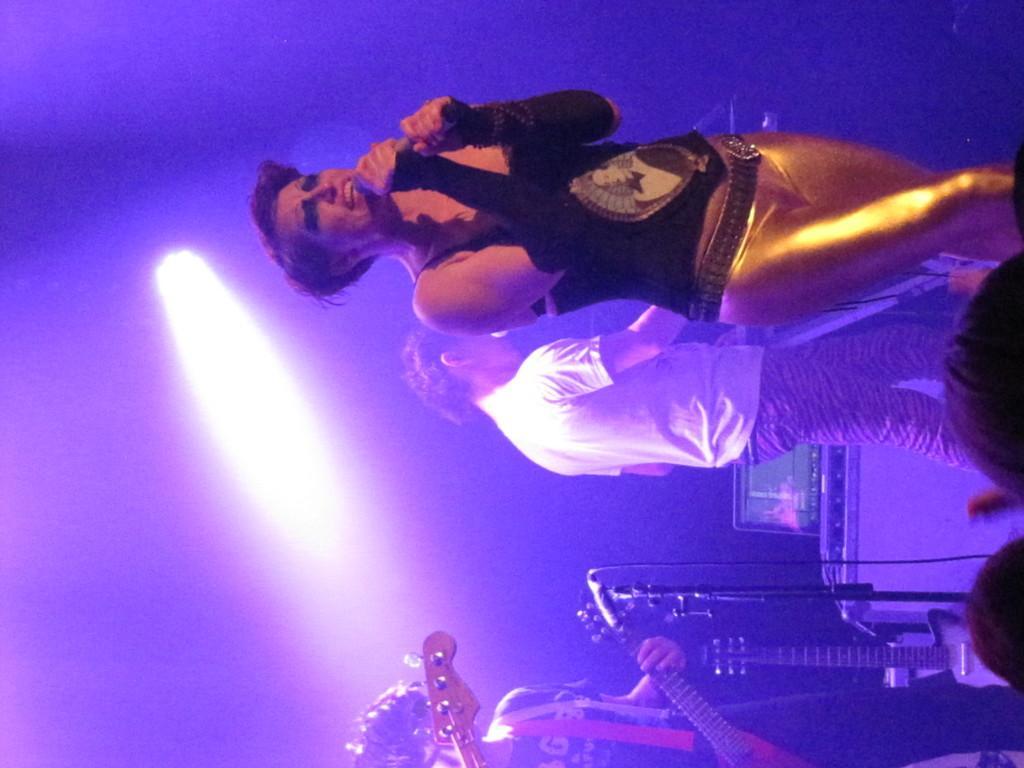Please provide a concise description of this image. In this image we can see some people standing on the stage. In that a man is holding a mic. On the left side we can see a man holding a guitar. We can also see a mike with a stand and dome lights. 